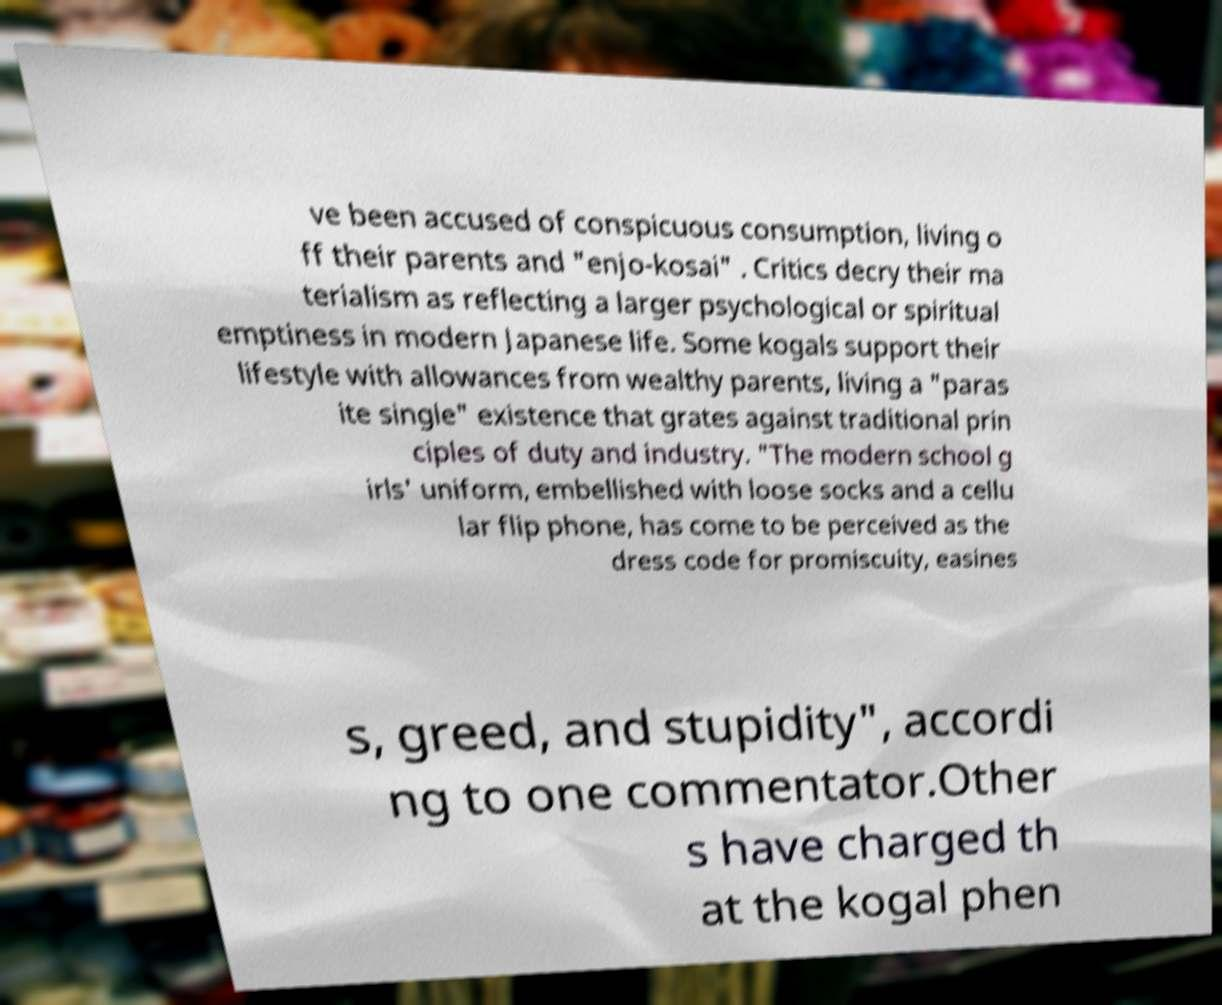What messages or text are displayed in this image? I need them in a readable, typed format. ve been accused of conspicuous consumption, living o ff their parents and "enjo-kosai" . Critics decry their ma terialism as reflecting a larger psychological or spiritual emptiness in modern Japanese life. Some kogals support their lifestyle with allowances from wealthy parents, living a "paras ite single" existence that grates against traditional prin ciples of duty and industry. "The modern school g irls' uniform, embellished with loose socks and a cellu lar flip phone, has come to be perceived as the dress code for promiscuity, easines s, greed, and stupidity", accordi ng to one commentator.Other s have charged th at the kogal phen 